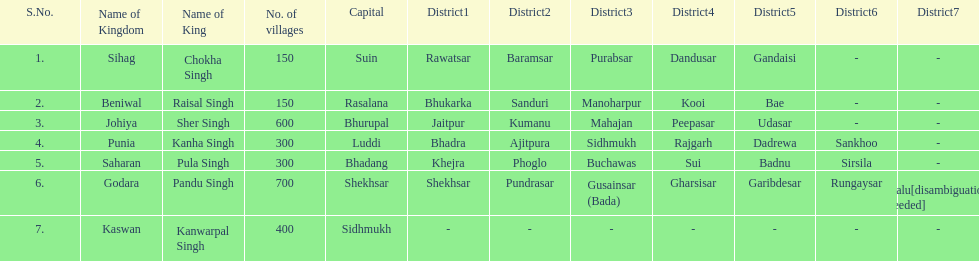What is the number of kingdoms that have more than 300 villages? 3. 